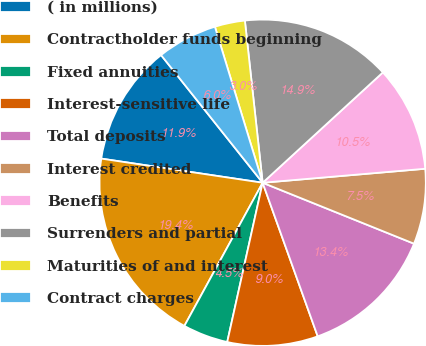<chart> <loc_0><loc_0><loc_500><loc_500><pie_chart><fcel>( in millions)<fcel>Contractholder funds beginning<fcel>Fixed annuities<fcel>Interest-sensitive life<fcel>Total deposits<fcel>Interest credited<fcel>Benefits<fcel>Surrenders and partial<fcel>Maturities of and interest<fcel>Contract charges<nl><fcel>11.94%<fcel>19.4%<fcel>4.48%<fcel>8.96%<fcel>13.43%<fcel>7.46%<fcel>10.45%<fcel>14.92%<fcel>2.99%<fcel>5.97%<nl></chart> 